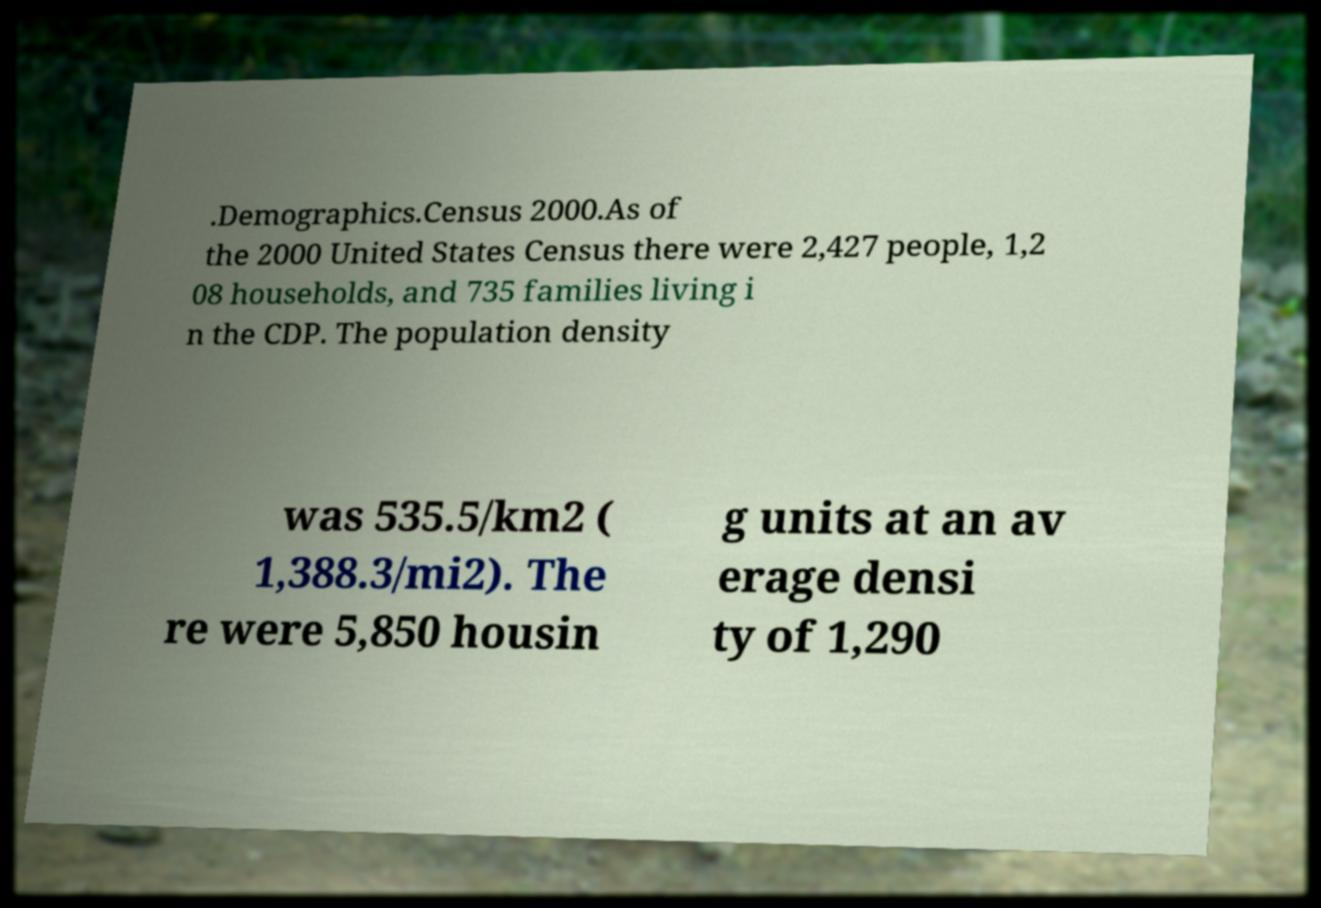Can you read and provide the text displayed in the image?This photo seems to have some interesting text. Can you extract and type it out for me? .Demographics.Census 2000.As of the 2000 United States Census there were 2,427 people, 1,2 08 households, and 735 families living i n the CDP. The population density was 535.5/km2 ( 1,388.3/mi2). The re were 5,850 housin g units at an av erage densi ty of 1,290 